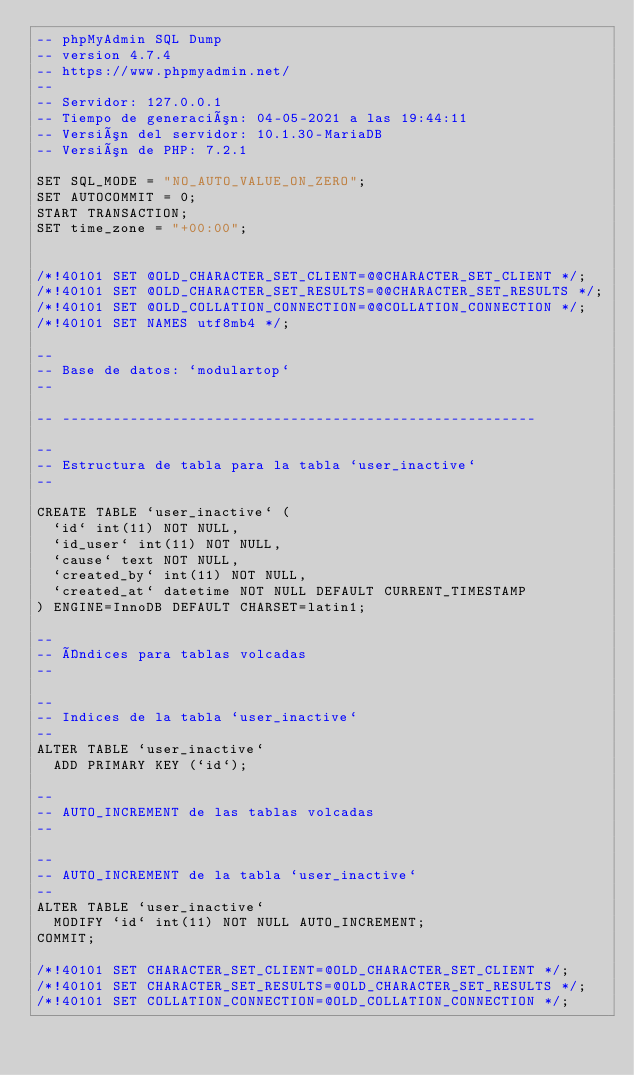<code> <loc_0><loc_0><loc_500><loc_500><_SQL_>-- phpMyAdmin SQL Dump
-- version 4.7.4
-- https://www.phpmyadmin.net/
--
-- Servidor: 127.0.0.1
-- Tiempo de generación: 04-05-2021 a las 19:44:11
-- Versión del servidor: 10.1.30-MariaDB
-- Versión de PHP: 7.2.1

SET SQL_MODE = "NO_AUTO_VALUE_ON_ZERO";
SET AUTOCOMMIT = 0;
START TRANSACTION;
SET time_zone = "+00:00";


/*!40101 SET @OLD_CHARACTER_SET_CLIENT=@@CHARACTER_SET_CLIENT */;
/*!40101 SET @OLD_CHARACTER_SET_RESULTS=@@CHARACTER_SET_RESULTS */;
/*!40101 SET @OLD_COLLATION_CONNECTION=@@COLLATION_CONNECTION */;
/*!40101 SET NAMES utf8mb4 */;

--
-- Base de datos: `modulartop`
--

-- --------------------------------------------------------

--
-- Estructura de tabla para la tabla `user_inactive`
--

CREATE TABLE `user_inactive` (
  `id` int(11) NOT NULL,
  `id_user` int(11) NOT NULL,
  `cause` text NOT NULL,
  `created_by` int(11) NOT NULL,
  `created_at` datetime NOT NULL DEFAULT CURRENT_TIMESTAMP
) ENGINE=InnoDB DEFAULT CHARSET=latin1;

--
-- Índices para tablas volcadas
--

--
-- Indices de la tabla `user_inactive`
--
ALTER TABLE `user_inactive`
  ADD PRIMARY KEY (`id`);

--
-- AUTO_INCREMENT de las tablas volcadas
--

--
-- AUTO_INCREMENT de la tabla `user_inactive`
--
ALTER TABLE `user_inactive`
  MODIFY `id` int(11) NOT NULL AUTO_INCREMENT;
COMMIT;

/*!40101 SET CHARACTER_SET_CLIENT=@OLD_CHARACTER_SET_CLIENT */;
/*!40101 SET CHARACTER_SET_RESULTS=@OLD_CHARACTER_SET_RESULTS */;
/*!40101 SET COLLATION_CONNECTION=@OLD_COLLATION_CONNECTION */;
</code> 